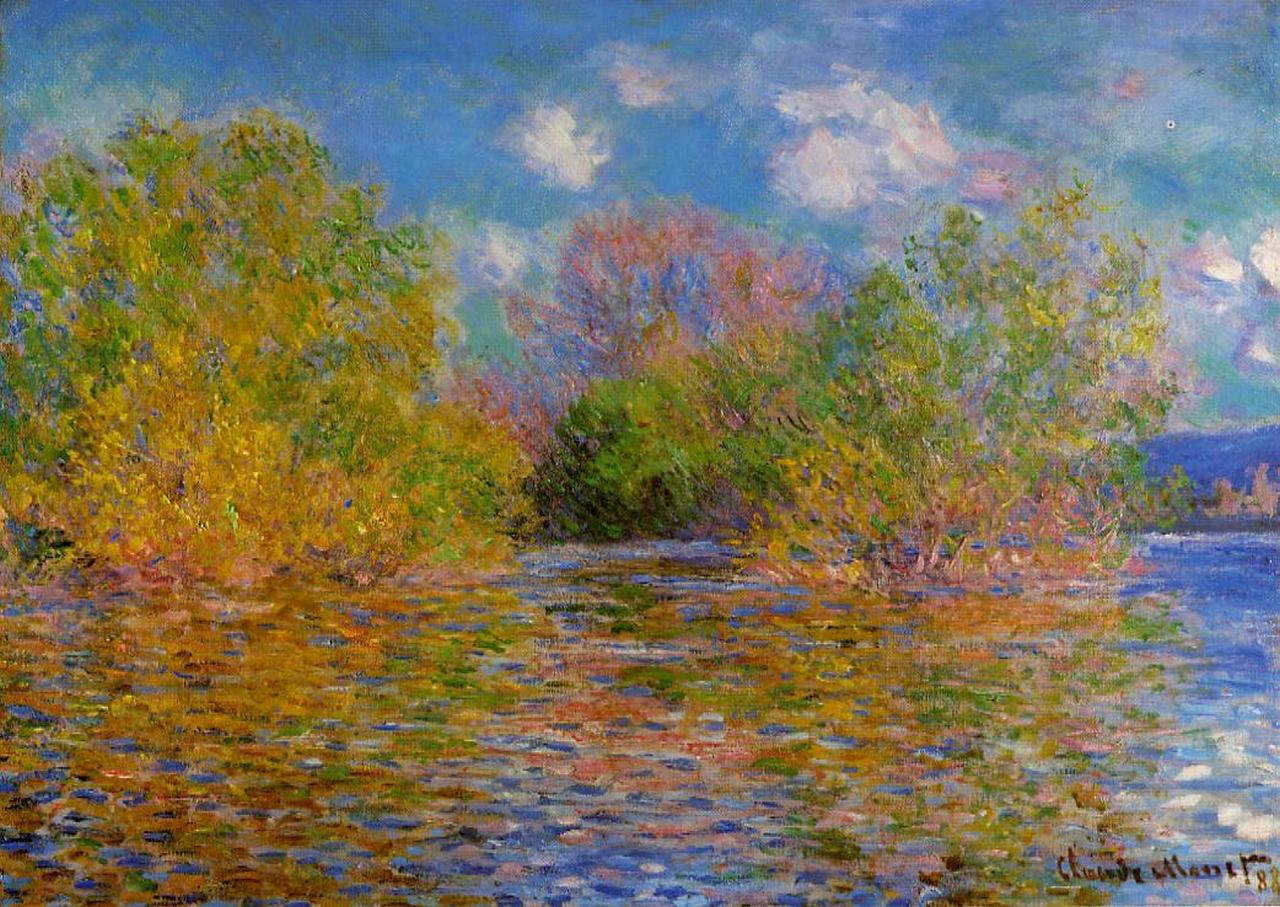Explain the visual content of the image in great detail. The image is a breathtaking representation of the Impressionist painting style, specifically a work by the renowned artist Claude Monet titled "The Seine at Argenteuil." It showcases a tranquil scene of the Seine river as it flows through Argenteuil, a charming commune in the northwestern suburbs of Paris, France.

In the foreground, the calm and reflective waters of the Seine dominate, mirroring the serene blue sky speckled with soft white clouds above. The riverbanks are lush with verdant trees and diverse foliage, presenting a vivid juxtaposition against the calm blue of the water and the ethereal sky. Monet's characteristic palette of blues, greens, and yellows is on full display, exuding a vibrant harmony that is quintessentially Monet.

Monet’s hallmark loose brushstrokes are meticulously applied throughout the painting, capturing the transient effects of natural light and color, which are iconic elements of the Impressionist movement. The overall composition emphasizes the ephemeral and atmospheric conditions, creating a scene that feels alive and ever-changing. This piece is a testament to Monet’s unparalleled ability to depict the essence of a moment, focusing not on intricate details but on the broader, more compelling impression. 